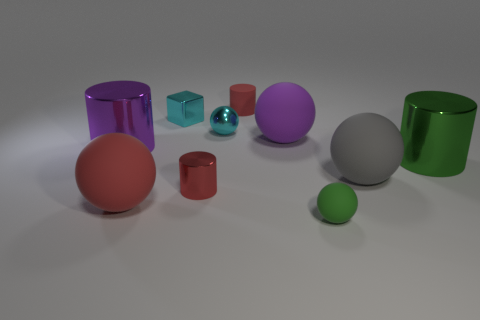There is a rubber sphere that is behind the gray matte ball; how big is it? The rubber sphere behind the gray matte ball appears to be slightly smaller. Given the relative size compared to the other objects in the image, it might be around two-thirds the diameter of the gray ball. 